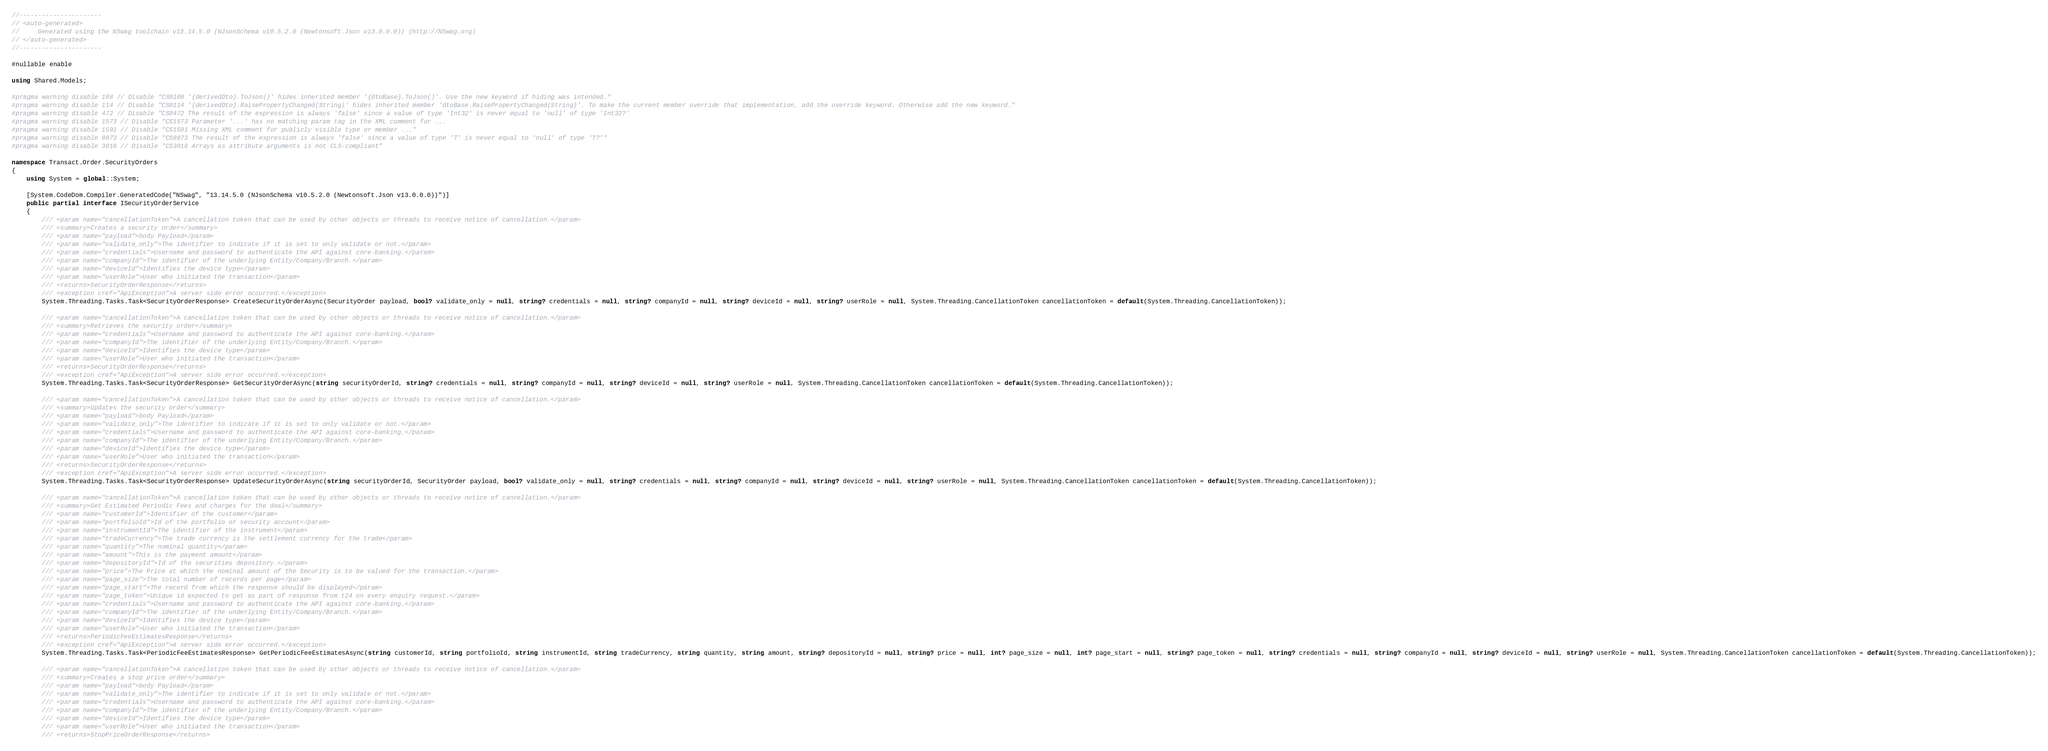<code> <loc_0><loc_0><loc_500><loc_500><_C#_>//----------------------
// <auto-generated>
//     Generated using the NSwag toolchain v13.14.5.0 (NJsonSchema v10.5.2.0 (Newtonsoft.Json v13.0.0.0)) (http://NSwag.org)
// </auto-generated>
//----------------------

#nullable enable

using Shared.Models;

#pragma warning disable 108 // Disable "CS0108 '{derivedDto}.ToJson()' hides inherited member '{dtoBase}.ToJson()'. Use the new keyword if hiding was intended."
#pragma warning disable 114 // Disable "CS0114 '{derivedDto}.RaisePropertyChanged(String)' hides inherited member 'dtoBase.RaisePropertyChanged(String)'. To make the current member override that implementation, add the override keyword. Otherwise add the new keyword."
#pragma warning disable 472 // Disable "CS0472 The result of the expression is always 'false' since a value of type 'Int32' is never equal to 'null' of type 'Int32?'
#pragma warning disable 1573 // Disable "CS1573 Parameter '...' has no matching param tag in the XML comment for ...
#pragma warning disable 1591 // Disable "CS1591 Missing XML comment for publicly visible type or member ..."
#pragma warning disable 8073 // Disable "CS8073 The result of the expression is always 'false' since a value of type 'T' is never equal to 'null' of type 'T?'"
#pragma warning disable 3016 // Disable "CS3016 Arrays as attribute arguments is not CLS-compliant"

namespace Transact.Order.SecurityOrders
{
    using System = global::System;

    [System.CodeDom.Compiler.GeneratedCode("NSwag", "13.14.5.0 (NJsonSchema v10.5.2.0 (Newtonsoft.Json v13.0.0.0))")]
    public partial interface ISecurityOrderService
    {
        /// <param name="cancellationToken">A cancellation token that can be used by other objects or threads to receive notice of cancellation.</param>
        /// <summary>Creates a security order</summary>
        /// <param name="payload">body Payload</param>
        /// <param name="validate_only">The identifier to indicate if it is set to only validate or not.</param>
        /// <param name="credentials">Username and password to authenticate the API against core-banking.</param>
        /// <param name="companyId">The identifier of the underlying Entity/Company/Branch.</param>
        /// <param name="deviceId">Identifies the device type</param>
        /// <param name="userRole">User who initiated the transaction</param>
        /// <returns>SecurityOrderResponse</returns>
        /// <exception cref="ApiException">A server side error occurred.</exception>
        System.Threading.Tasks.Task<SecurityOrderResponse> CreateSecurityOrderAsync(SecurityOrder payload, bool? validate_only = null, string? credentials = null, string? companyId = null, string? deviceId = null, string? userRole = null, System.Threading.CancellationToken cancellationToken = default(System.Threading.CancellationToken));
    
        /// <param name="cancellationToken">A cancellation token that can be used by other objects or threads to receive notice of cancellation.</param>
        /// <summary>Retrieves the security order</summary>
        /// <param name="credentials">Username and password to authenticate the API against core-banking.</param>
        /// <param name="companyId">The identifier of the underlying Entity/Company/Branch.</param>
        /// <param name="deviceId">Identifies the device type</param>
        /// <param name="userRole">User who initiated the transaction</param>
        /// <returns>SecurityOrderResponse</returns>
        /// <exception cref="ApiException">A server side error occurred.</exception>
        System.Threading.Tasks.Task<SecurityOrderResponse> GetSecurityOrderAsync(string securityOrderId, string? credentials = null, string? companyId = null, string? deviceId = null, string? userRole = null, System.Threading.CancellationToken cancellationToken = default(System.Threading.CancellationToken));
    
        /// <param name="cancellationToken">A cancellation token that can be used by other objects or threads to receive notice of cancellation.</param>
        /// <summary>Updates the security order</summary>
        /// <param name="payload">body Payload</param>
        /// <param name="validate_only">The identifier to indicate if it is set to only validate or not.</param>
        /// <param name="credentials">Username and password to authenticate the API against core-banking.</param>
        /// <param name="companyId">The identifier of the underlying Entity/Company/Branch.</param>
        /// <param name="deviceId">Identifies the device type</param>
        /// <param name="userRole">User who initiated the transaction</param>
        /// <returns>SecurityOrderResponse</returns>
        /// <exception cref="ApiException">A server side error occurred.</exception>
        System.Threading.Tasks.Task<SecurityOrderResponse> UpdateSecurityOrderAsync(string securityOrderId, SecurityOrder payload, bool? validate_only = null, string? credentials = null, string? companyId = null, string? deviceId = null, string? userRole = null, System.Threading.CancellationToken cancellationToken = default(System.Threading.CancellationToken));
    
        /// <param name="cancellationToken">A cancellation token that can be used by other objects or threads to receive notice of cancellation.</param>
        /// <summary>Get Estimated Periodic Fees and charges for the deal</summary>
        /// <param name="customerId">Identifier of the customer</param>
        /// <param name="portfolioId">Id of the portfolio or security account</param>
        /// <param name="instrumentId">The identifier of the instrument</param>
        /// <param name="tradeCurrency">The trade currency is the settlement currency for the trade</param>
        /// <param name="quantity">The nominal quantity</param>
        /// <param name="amount">This is the payment amount</param>
        /// <param name="depositoryId">Id of the securities depository.</param>
        /// <param name="price">The Price at which the nominal amount of the Security is to be valued for the transaction.</param>
        /// <param name="page_size">The total number of records per page</param>
        /// <param name="page_start">The record from which the response should be displayed</param>
        /// <param name="page_token">Unique id expected to get as part of response from t24 on every enquiry request.</param>
        /// <param name="credentials">Username and password to authenticate the API against core-banking.</param>
        /// <param name="companyId">The identifier of the underlying Entity/Company/Branch.</param>
        /// <param name="deviceId">Identifies the device type</param>
        /// <param name="userRole">User who initiated the transaction</param>
        /// <returns>PeriodicFeeEstimatesResponse</returns>
        /// <exception cref="ApiException">A server side error occurred.</exception>
        System.Threading.Tasks.Task<PeriodicFeeEstimatesResponse> GetPeriodicFeeEstimatesAsync(string customerId, string portfolioId, string instrumentId, string tradeCurrency, string quantity, string amount, string? depositoryId = null, string? price = null, int? page_size = null, int? page_start = null, string? page_token = null, string? credentials = null, string? companyId = null, string? deviceId = null, string? userRole = null, System.Threading.CancellationToken cancellationToken = default(System.Threading.CancellationToken));
    
        /// <param name="cancellationToken">A cancellation token that can be used by other objects or threads to receive notice of cancellation.</param>
        /// <summary>Creates a stop price order</summary>
        /// <param name="payload">body Payload</param>
        /// <param name="validate_only">The identifier to indicate if it is set to only validate or not.</param>
        /// <param name="credentials">Username and password to authenticate the API against core-banking.</param>
        /// <param name="companyId">The identifier of the underlying Entity/Company/Branch.</param>
        /// <param name="deviceId">Identifies the device type</param>
        /// <param name="userRole">User who initiated the transaction</param>
        /// <returns>StopPriceOrderResponse</returns></code> 